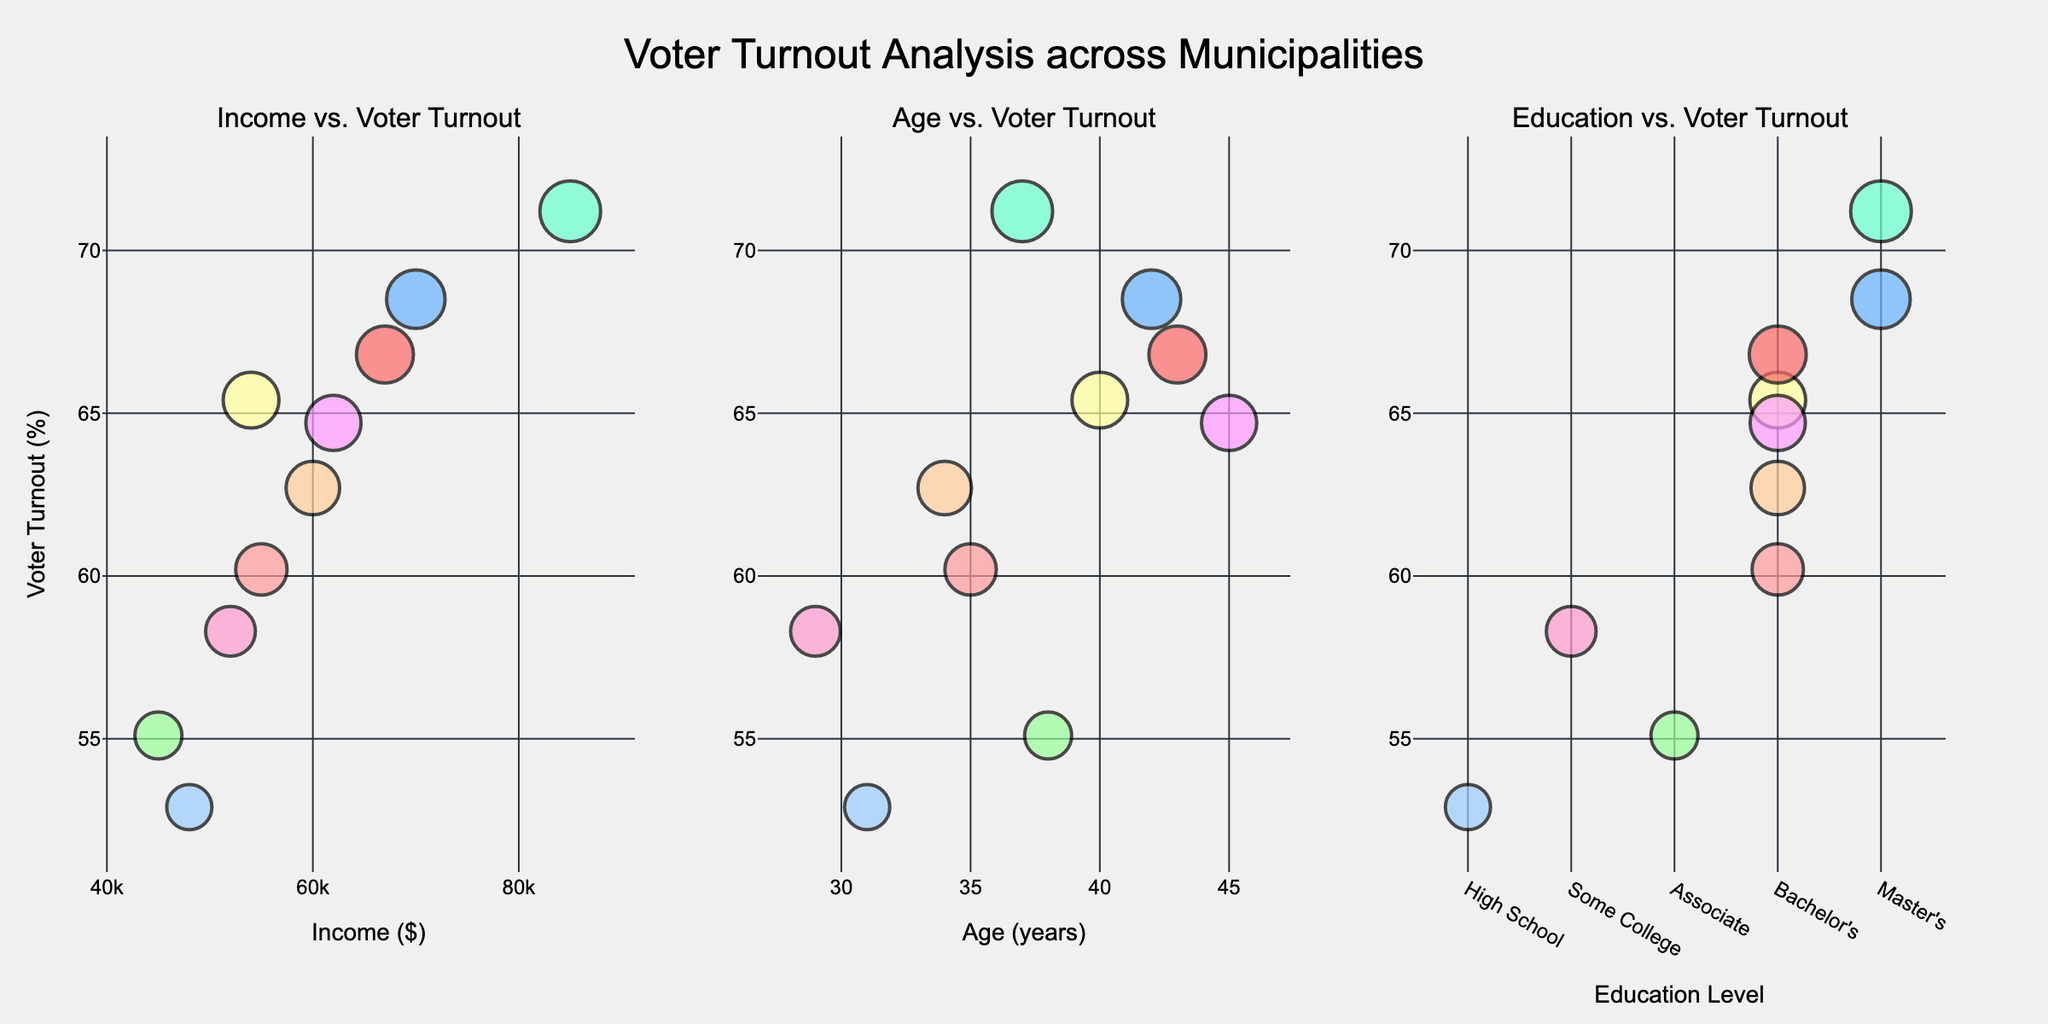What is the title of the figure? The title is located at the top center of the figure, and it reads "Voter Turnout Analysis across Municipalities."
Answer: Voter Turnout Analysis across Municipalities Which subplot shows the relationship between Income and Voter Turnout? The subplot labels provide the information. The label "Income vs. Voter Turnout" is above the first subplot from the left.
Answer: The first subplot from the left What is the average voter turnout rate across all municipalities? Sum and count all the voter turnout rates from the data: (60.2 + 68.5 + 55.1 + 62.7 + 58.3 + 52.9 + 65.4 + 64.7 + 71.2 + 66.8) / 10.
Answer: 62.6 Which municipality has the highest voter turnout rate and what is their voter turnout rate? Look for the largest bubble on any of the subplots and hover over it to see the label. Irvine has the largest bubble with a voter turnout rate of 71.2%.
Answer: Irvine, 71.2% Is there a positive correlation between Income and Voter Turnout? Observe the pattern of bubbles in the Income vs. Voter Turnout subplot. It shows that higher income municipalities tend to have higher voter turnout rates.
Answer: Yes Which age group tends to have the highest voter turnout? Locate the age range with the largest bubbles in the Age vs. Voter Turnout subplot, indicating high turnout rates. The 37-43 age group has larger bubbles.
Answer: 37-43 Compare the voter turnout rates between municipalities where the highest educational level is a Master's Degree and those where it is a Bachelor's Degree. Identify which bubbles belong to municipalities with Master's and Bachelor's degrees by their color and size. Master's Degree municipalities (Boston, Irvine) have 68.5% and 71.2%; Bachelor's Degree (Austin, Denver, Gainesville, Hartford, Jersey City) have lower rates on average.
Answer: Master's Degree municipalities have higher voter turnout rates on average How many municipalities have a voter turnout rate above 60%? Count all bubbles with y-values (Voter Turnout) above 60% across all subplots. Austin, Boston, Denver, Gainesville, Hartford, Irvine, Jersey City count up to 7.
Answer: 7 Which subplot has bubbles with the most diverse colors? Observe the number of unique colors in the markers on each subplot. The "Education vs. Voter Turnout" subplot has the most diverse colors representing different education levels.
Answer: Education vs. Voter Turnout What is the voter turnout rate in Gainesville compared to Jersey City? Check the sizes and hover text of the bubbles in all subplots. Gainesville's voter turnout rate is 65.4%, and Jersey City's is 66.8%, making Jersey City's slightly higher.
Answer: Jersey City has a slightly higher turnout rate than Gainesville 